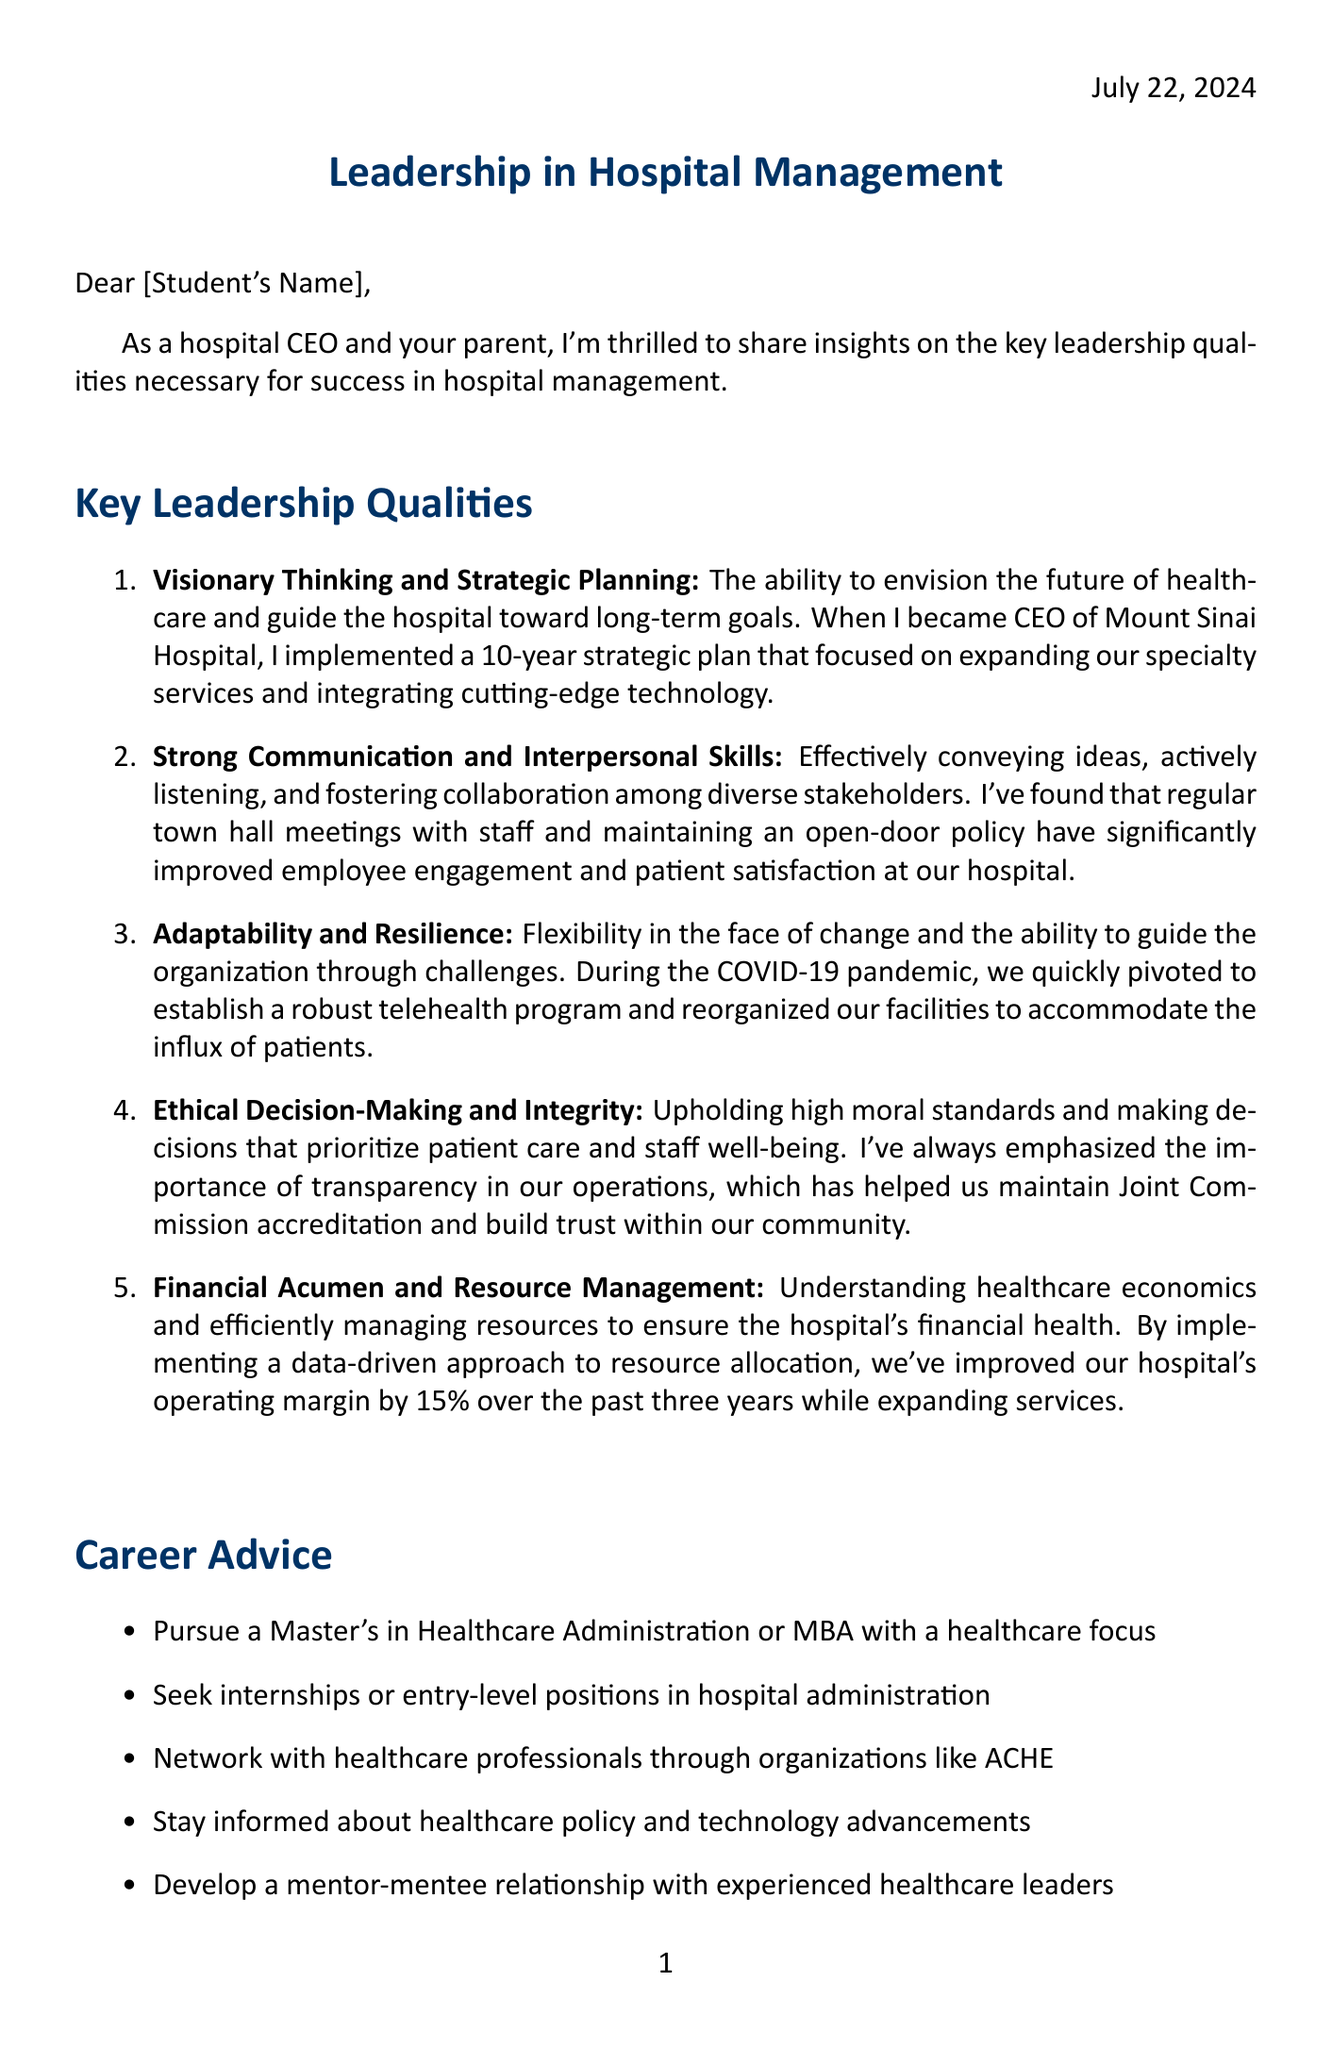What is the title of the letter? The title of the letter is indicated at the beginning of the document and is "Leadership in Hospital Management."
Answer: Leadership in Hospital Management Who is the author of the letter? The author of the letter is indicated as the parent and a hospital CEO, but the specific name is not provided in the document. The placeholder is "[Your Name]."
Answer: [Your Name] What is one key leadership quality mentioned in the letter? The letter lists several key leadership qualities, one of which is "Visionary Thinking and Strategic Planning."
Answer: Visionary Thinking and Strategic Planning During what period did the author serve as CEO of Mount Sinai Hospital? The letter provides the author's duration as CEO of Mount Sinai Hospital which is from 2015 to present.
Answer: 2015 - Present What major event did the author adapt the hospital's operations during? The author mentions adapting operations during the "COVID-19 pandemic."
Answer: COVID-19 pandemic How much did the hospital's operating margin improve over the past three years? The letter states that the operating margin improved by 15% due to a data-driven resource allocation approach.
Answer: 15% What is one piece of career advice given to the student? The letter includes several career advice points, one of which is to "Pursue a Master's in Healthcare Administration or MBA with a healthcare focus."
Answer: Pursue a Master's in Healthcare Administration or MBA with a healthcare focus What is highlighted as a challenge faced in the healthcare industry? The letter identifies "Rising healthcare costs" as one of the challenges faced in the healthcare industry.
Answer: Rising healthcare costs What role does the author hold in the American Hospital Association? The author serves as a "Board Member" in the American Hospital Association according to the document.
Answer: Board Member 